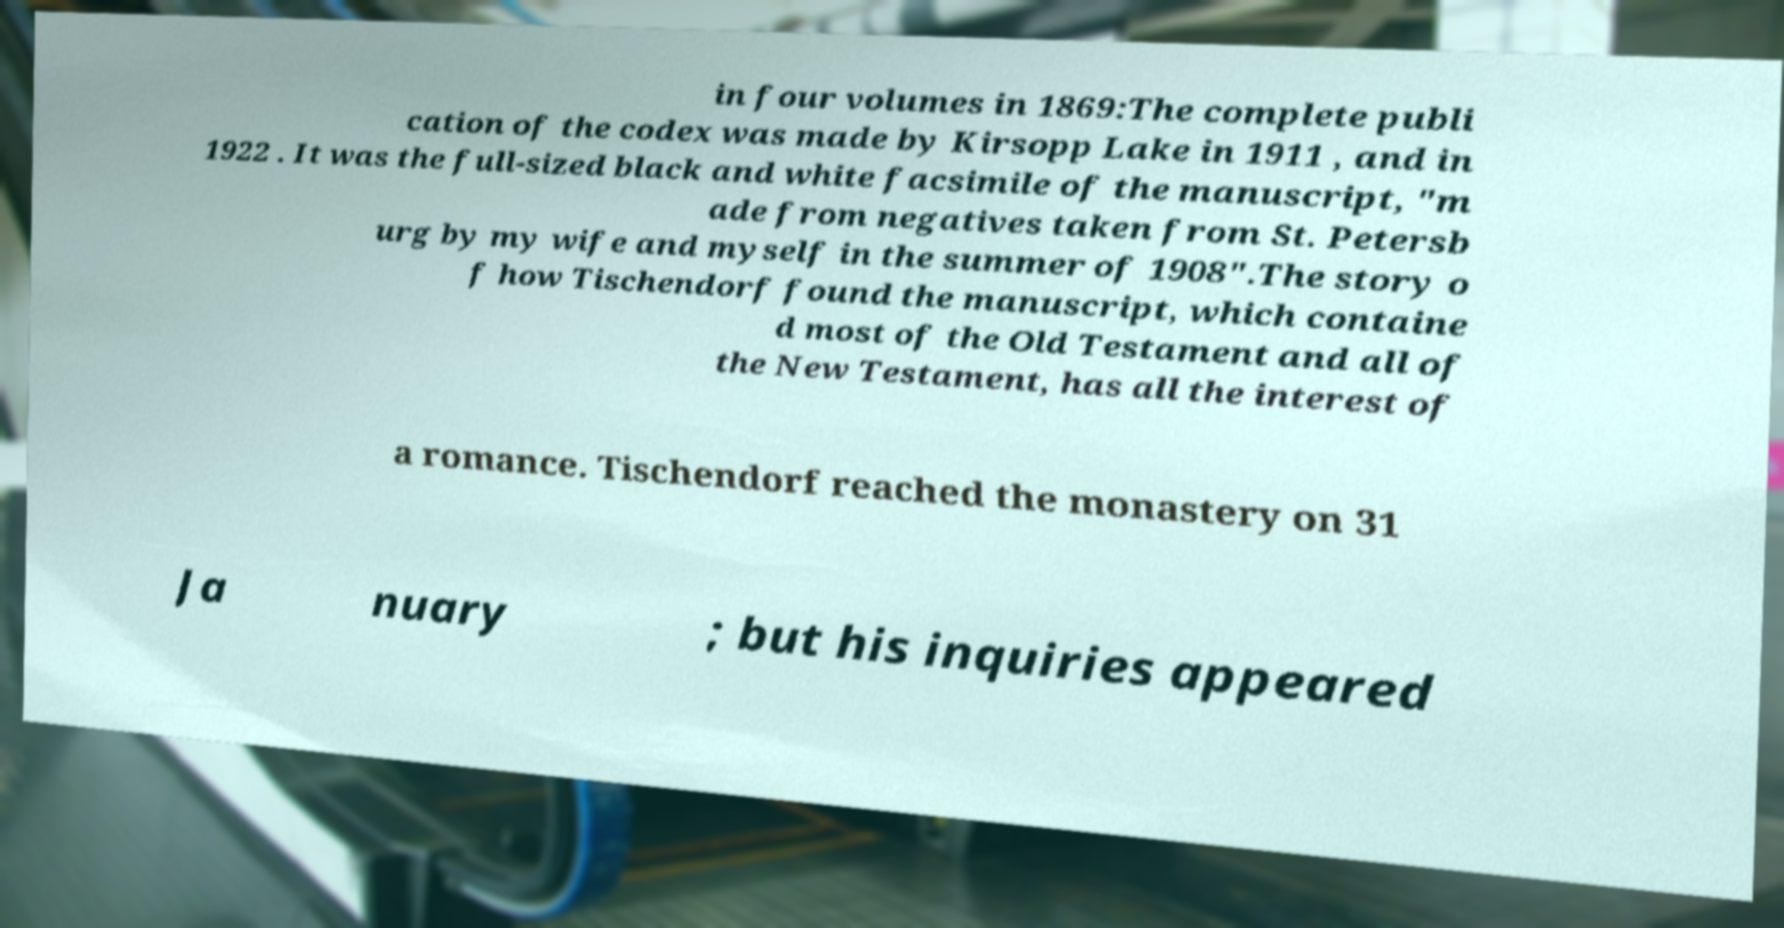Can you accurately transcribe the text from the provided image for me? in four volumes in 1869:The complete publi cation of the codex was made by Kirsopp Lake in 1911 , and in 1922 . It was the full-sized black and white facsimile of the manuscript, "m ade from negatives taken from St. Petersb urg by my wife and myself in the summer of 1908".The story o f how Tischendorf found the manuscript, which containe d most of the Old Testament and all of the New Testament, has all the interest of a romance. Tischendorf reached the monastery on 31 Ja nuary ; but his inquiries appeared 